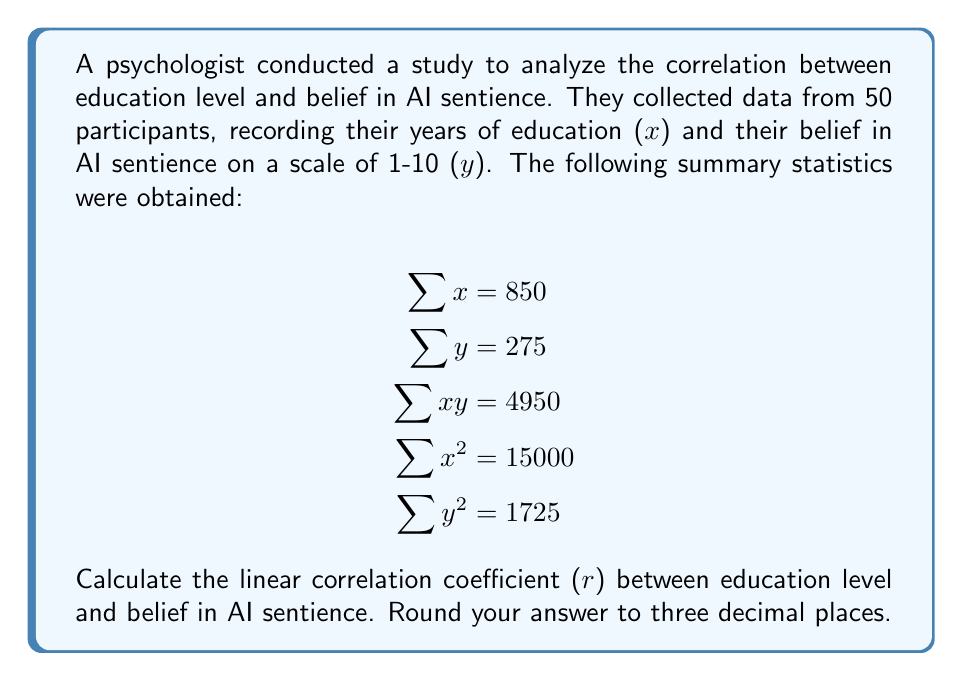Teach me how to tackle this problem. To calculate the linear correlation coefficient (r), we'll use the formula:

$$r = \frac{n\sum xy - \sum x \sum y}{\sqrt{[n\sum x^2 - (\sum x)^2][n\sum y^2 - (\sum y)^2]}}$$

Where n is the number of participants (50 in this case).

Step 1: Calculate $n\sum xy$
$n\sum xy = 50 \cdot 4950 = 247500$

Step 2: Calculate $\sum x \sum y$
$\sum x \sum y = 850 \cdot 275 = 233750$

Step 3: Calculate the numerator
$n\sum xy - \sum x \sum y = 247500 - 233750 = 13750$

Step 4: Calculate $n\sum x^2$
$n\sum x^2 = 50 \cdot 15000 = 750000$

Step 5: Calculate $(\sum x)^2$
$(\sum x)^2 = 850^2 = 722500$

Step 6: Calculate $n\sum y^2$
$n\sum y^2 = 50 \cdot 1725 = 86250$

Step 7: Calculate $(\sum y)^2$
$(\sum y)^2 = 275^2 = 75625$

Step 8: Calculate the denominator
$\sqrt{[n\sum x^2 - (\sum x)^2][n\sum y^2 - (\sum y)^2]}$
$= \sqrt{[750000 - 722500][86250 - 75625]}$
$= \sqrt{27500 \cdot 10625}$
$= \sqrt{292187500}$
$= 17093.75$

Step 9: Calculate r
$r = \frac{13750}{17093.75} = 0.804$

Therefore, the linear correlation coefficient (r) rounded to three decimal places is 0.804.
Answer: 0.804 